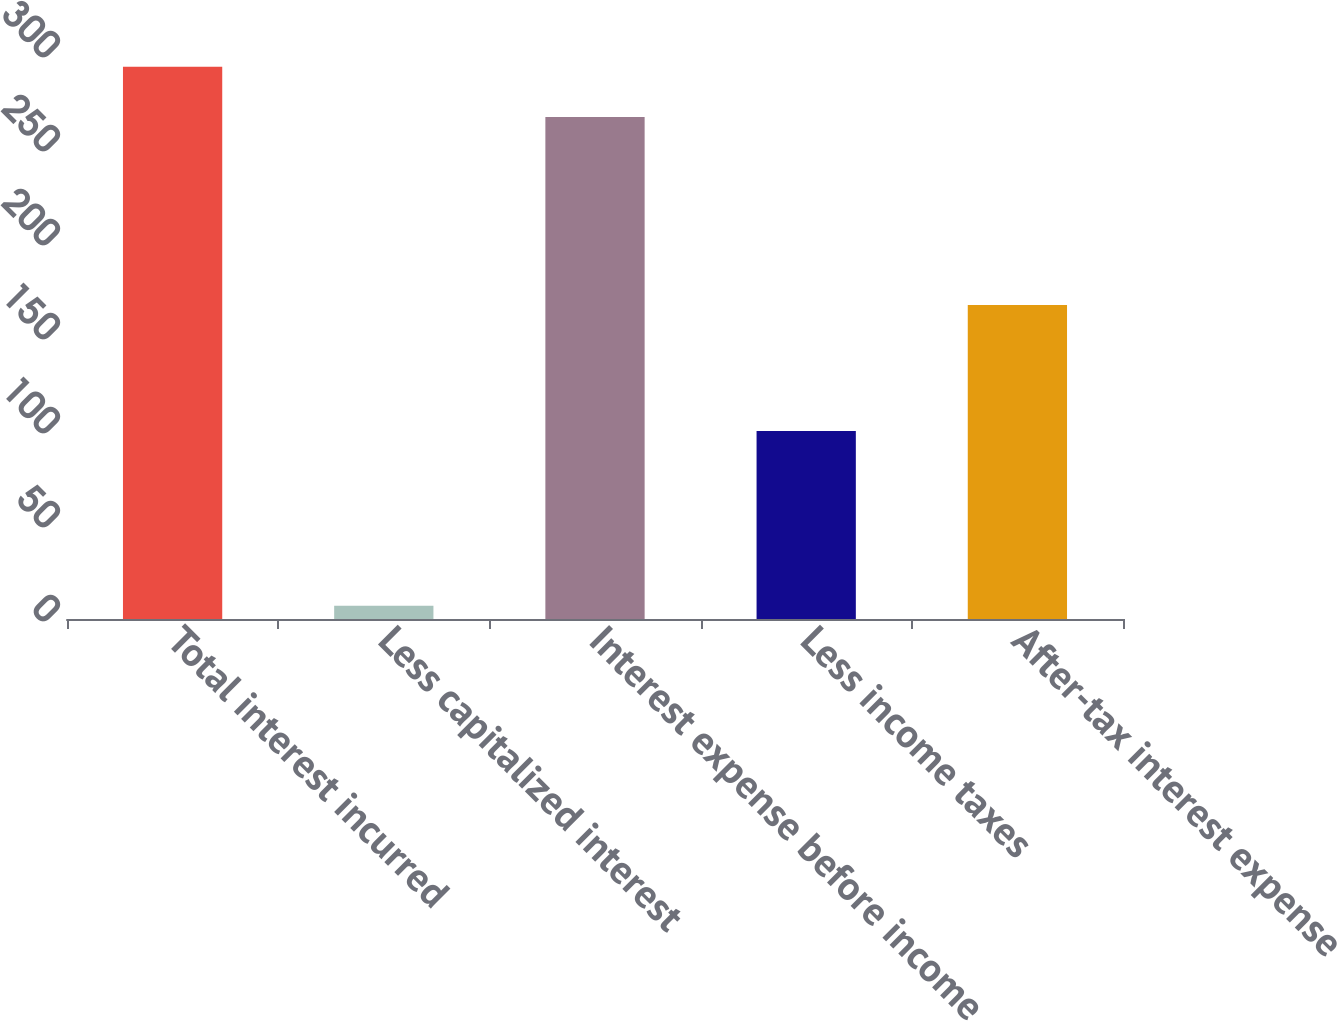Convert chart. <chart><loc_0><loc_0><loc_500><loc_500><bar_chart><fcel>Total interest incurred<fcel>Less capitalized interest<fcel>Interest expense before income<fcel>Less income taxes<fcel>After-tax interest expense<nl><fcel>293.7<fcel>7<fcel>267<fcel>100<fcel>167<nl></chart> 